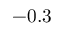<formula> <loc_0><loc_0><loc_500><loc_500>- 0 . 3</formula> 